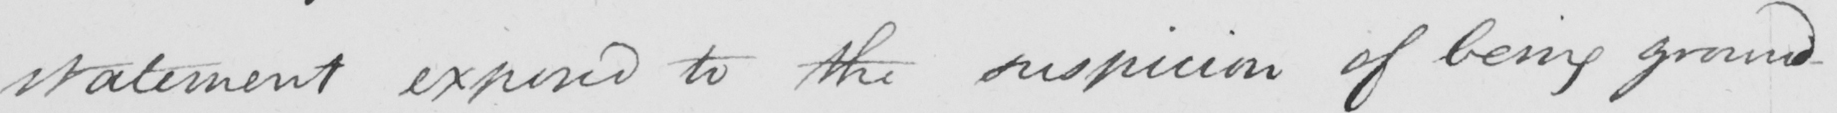What does this handwritten line say? statement exposed to the suspicion of being ground- 